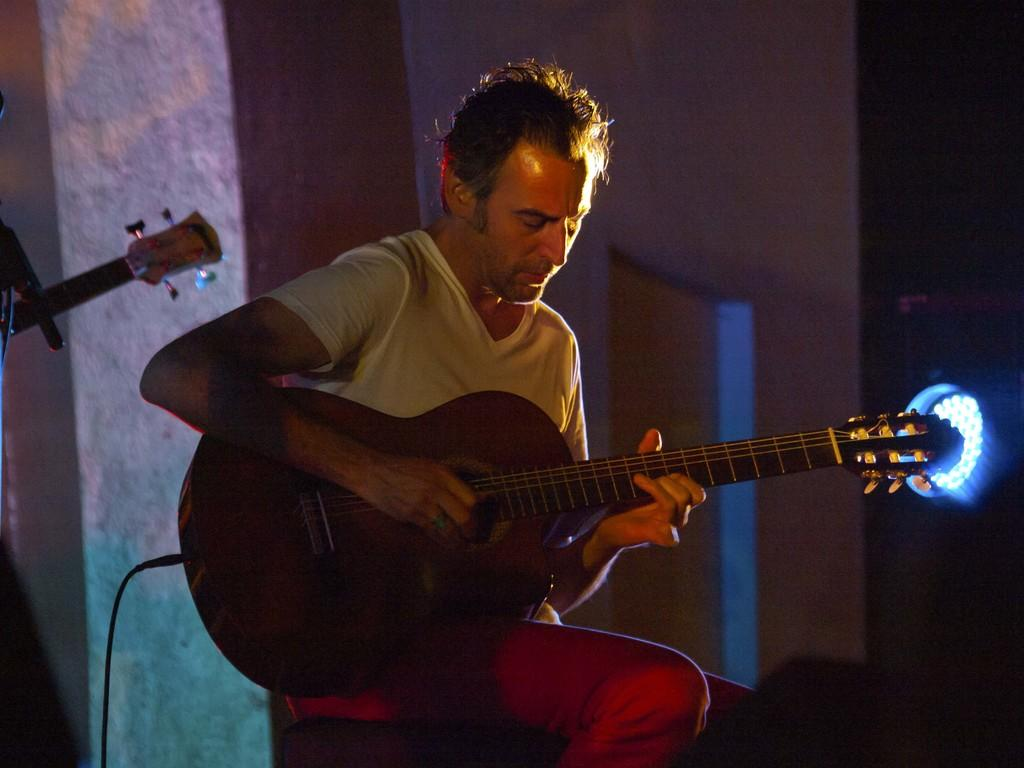What is the man in the image doing? The man is playing a guitar. What is the man wearing in the image? The man is wearing a white t-shirt. What is the man's position in the image? The man is sitting. What can be seen on the right side of the image? There is a light on the right side of the image. What type of sack can be seen in the image? There is no sack present in the image. What is the taste of the guitar in the image? Guitars do not have a taste, as they are musical instruments and not food items. 